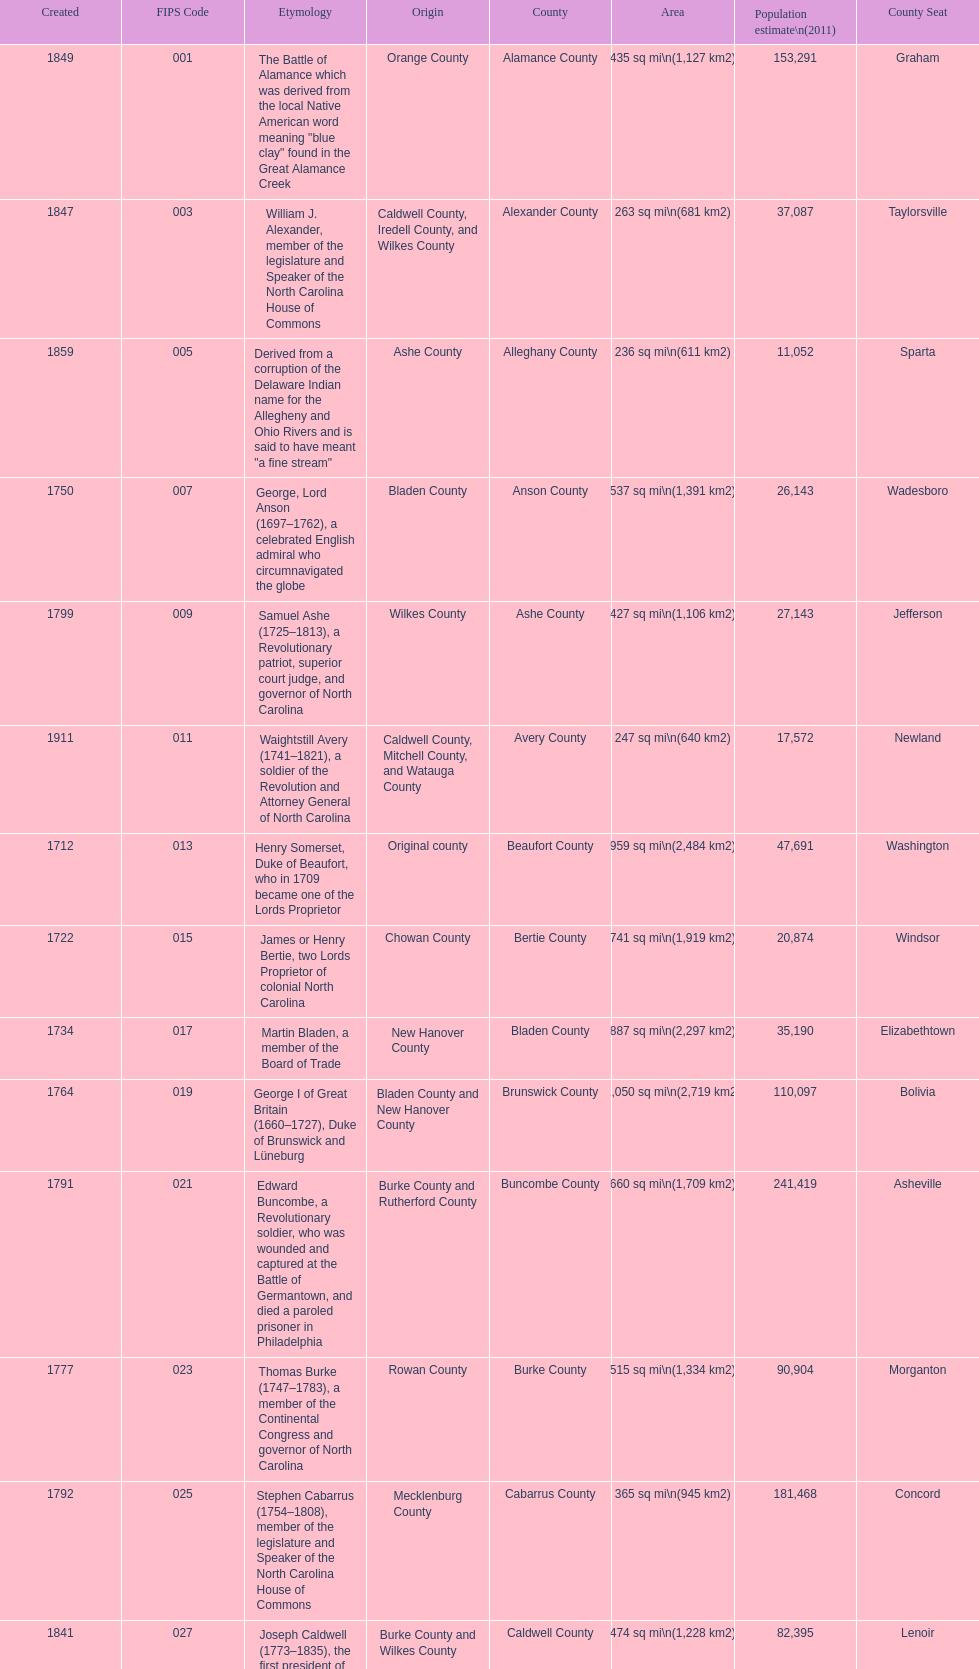What is the only county whose name comes from a battle? Alamance County. 